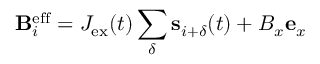<formula> <loc_0><loc_0><loc_500><loc_500>{ B } _ { i } ^ { e f f } = J _ { e x } ( t ) \sum _ { \delta } { s } _ { i + \delta } ( t ) + B _ { x } { e } _ { x }</formula> 